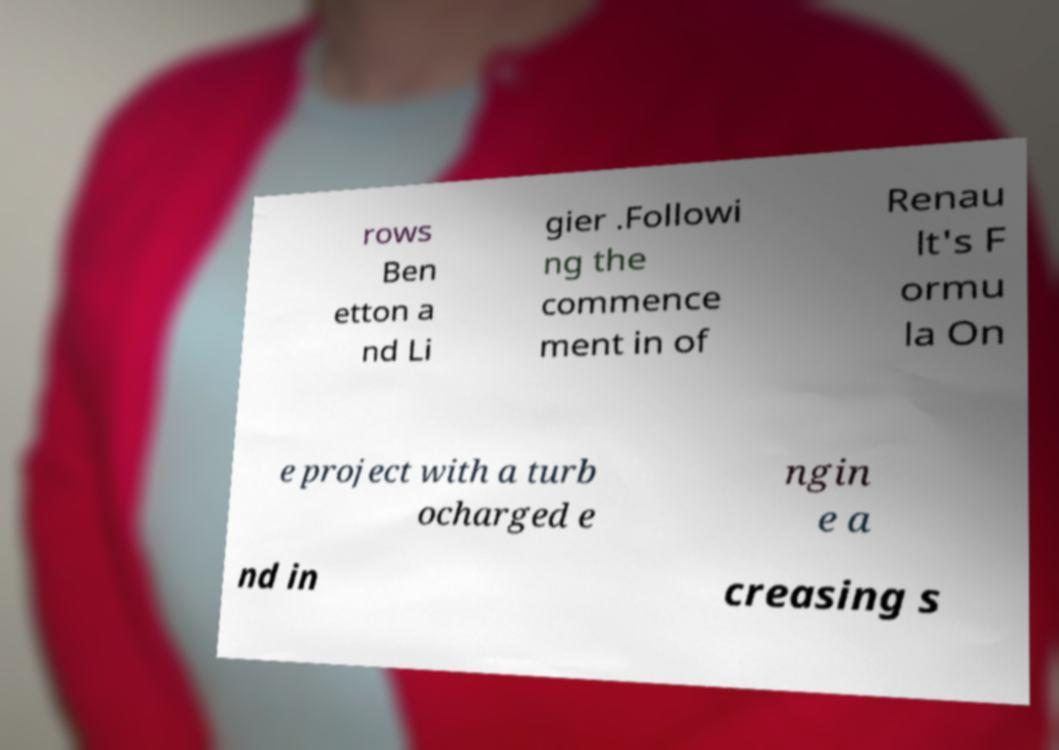There's text embedded in this image that I need extracted. Can you transcribe it verbatim? rows Ben etton a nd Li gier .Followi ng the commence ment in of Renau lt's F ormu la On e project with a turb ocharged e ngin e a nd in creasing s 